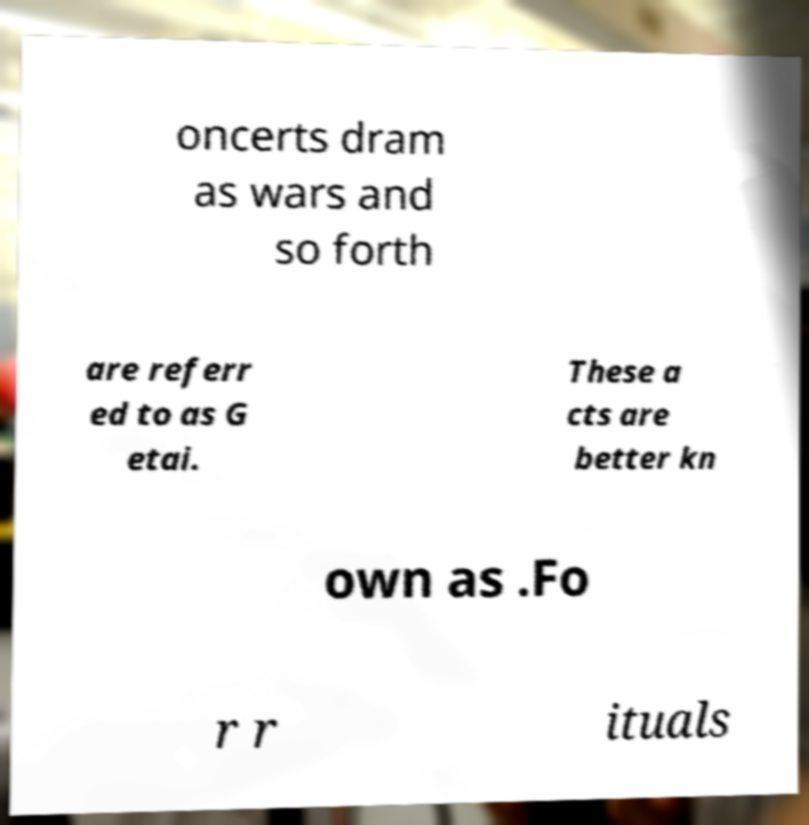For documentation purposes, I need the text within this image transcribed. Could you provide that? oncerts dram as wars and so forth are referr ed to as G etai. These a cts are better kn own as .Fo r r ituals 